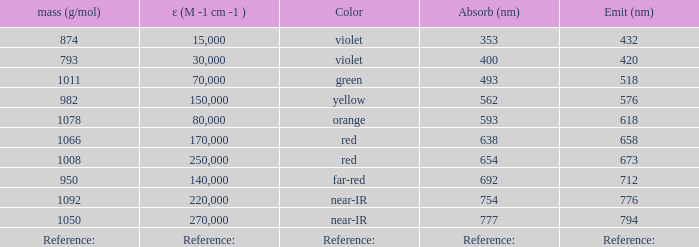Would you be able to parse every entry in this table? {'header': ['mass (g/mol)', 'ε (M -1 cm -1 )', 'Color', 'Absorb (nm)', 'Emit (nm)'], 'rows': [['874', '15,000', 'violet', '353', '432'], ['793', '30,000', 'violet', '400', '420'], ['1011', '70,000', 'green', '493', '518'], ['982', '150,000', 'yellow', '562', '576'], ['1078', '80,000', 'orange', '593', '618'], ['1066', '170,000', 'red', '638', '658'], ['1008', '250,000', 'red', '654', '673'], ['950', '140,000', 'far-red', '692', '712'], ['1092', '220,000', 'near-IR', '754', '776'], ['1050', '270,000', 'near-IR', '777', '794'], ['Reference:', 'Reference:', 'Reference:', 'Reference:', 'Reference:']]} What is the Absorbtion (in nanometers) of the color Orange? 593.0. 